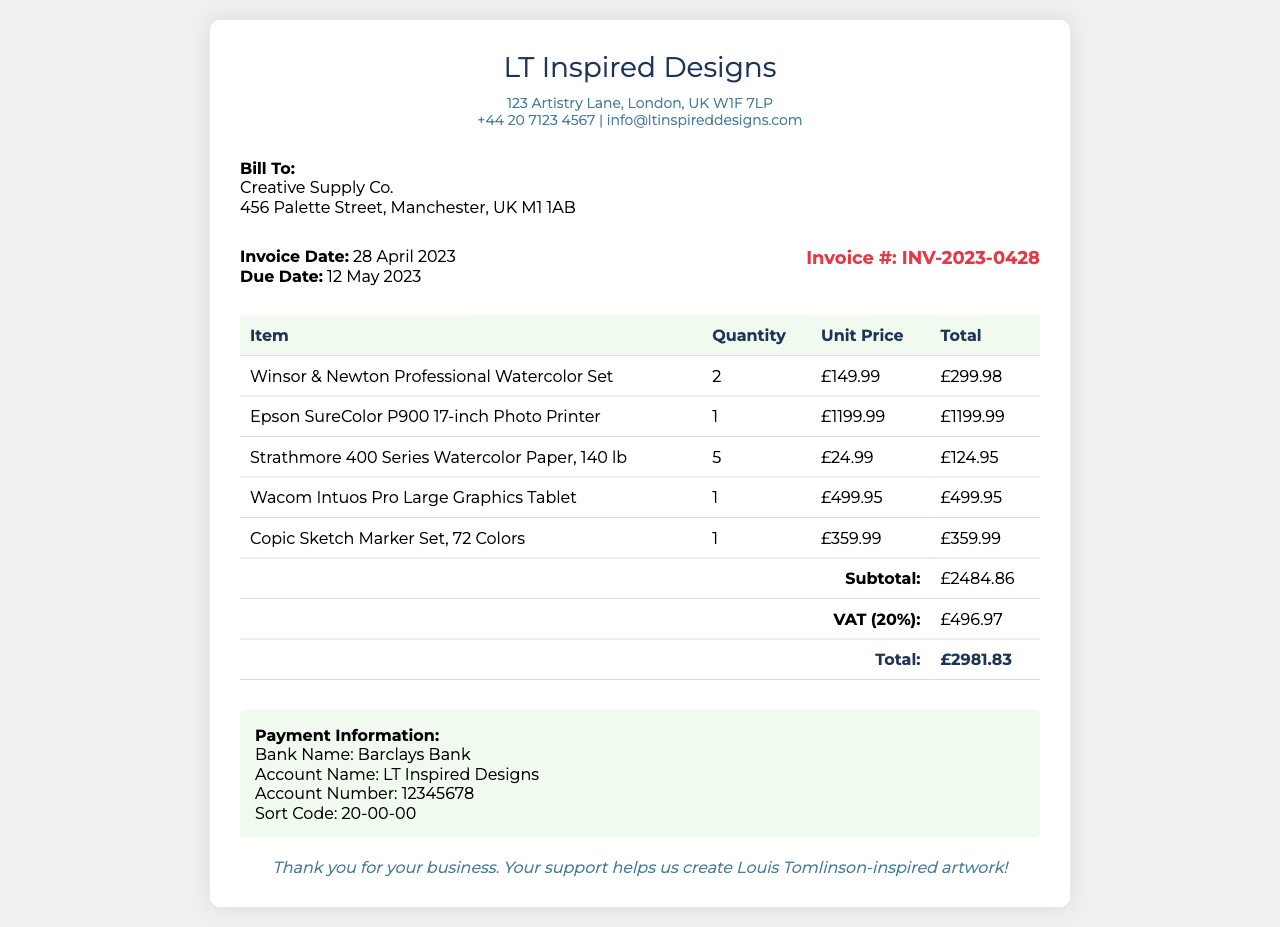What is the invoice date? The invoice date is specified in the document under invoice details.
Answer: 28 April 2023 Who is the bill to? The recipient's name is mentioned in the recipient section of the document.
Answer: Creative Supply Co What is the total amount due? The total amount due is noted in the document under the total row in the table.
Answer: £2981.83 How many Winsor & Newton Professional Watercolor Sets were ordered? The quantity of Winsor & Newton Professional Watercolor Sets is indicated in the itemized list.
Answer: 2 What is the unit price of the Epson SureColor P900 printer? The unit price is provided in the itemized list in the table.
Answer: £1199.99 What is the VAT rate applied in the invoice? The VAT rate is inferred from the VAT amount mentioned in the subtotal section.
Answer: 20% What is the payment account name? The payment information section contains the account name for the payment.
Answer: LT Inspired Designs What type of document is this? The purpose of the document is indicated in the title of the document and the content structure.
Answer: Invoice 